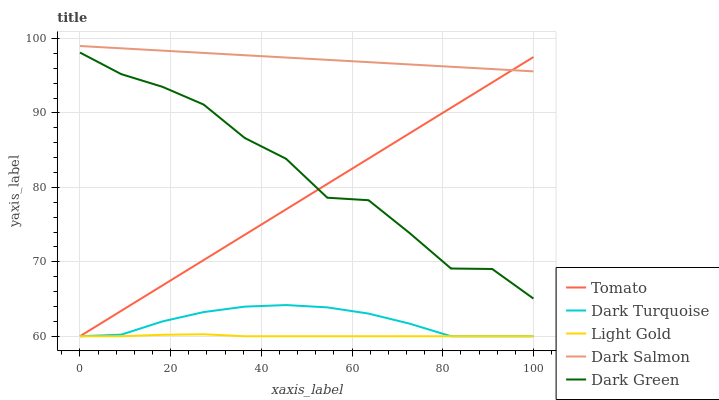Does Light Gold have the minimum area under the curve?
Answer yes or no. Yes. Does Dark Salmon have the maximum area under the curve?
Answer yes or no. Yes. Does Dark Turquoise have the minimum area under the curve?
Answer yes or no. No. Does Dark Turquoise have the maximum area under the curve?
Answer yes or no. No. Is Dark Salmon the smoothest?
Answer yes or no. Yes. Is Dark Green the roughest?
Answer yes or no. Yes. Is Dark Turquoise the smoothest?
Answer yes or no. No. Is Dark Turquoise the roughest?
Answer yes or no. No. Does Tomato have the lowest value?
Answer yes or no. Yes. Does Dark Salmon have the lowest value?
Answer yes or no. No. Does Dark Salmon have the highest value?
Answer yes or no. Yes. Does Dark Turquoise have the highest value?
Answer yes or no. No. Is Dark Green less than Dark Salmon?
Answer yes or no. Yes. Is Dark Salmon greater than Dark Turquoise?
Answer yes or no. Yes. Does Tomato intersect Dark Green?
Answer yes or no. Yes. Is Tomato less than Dark Green?
Answer yes or no. No. Is Tomato greater than Dark Green?
Answer yes or no. No. Does Dark Green intersect Dark Salmon?
Answer yes or no. No. 